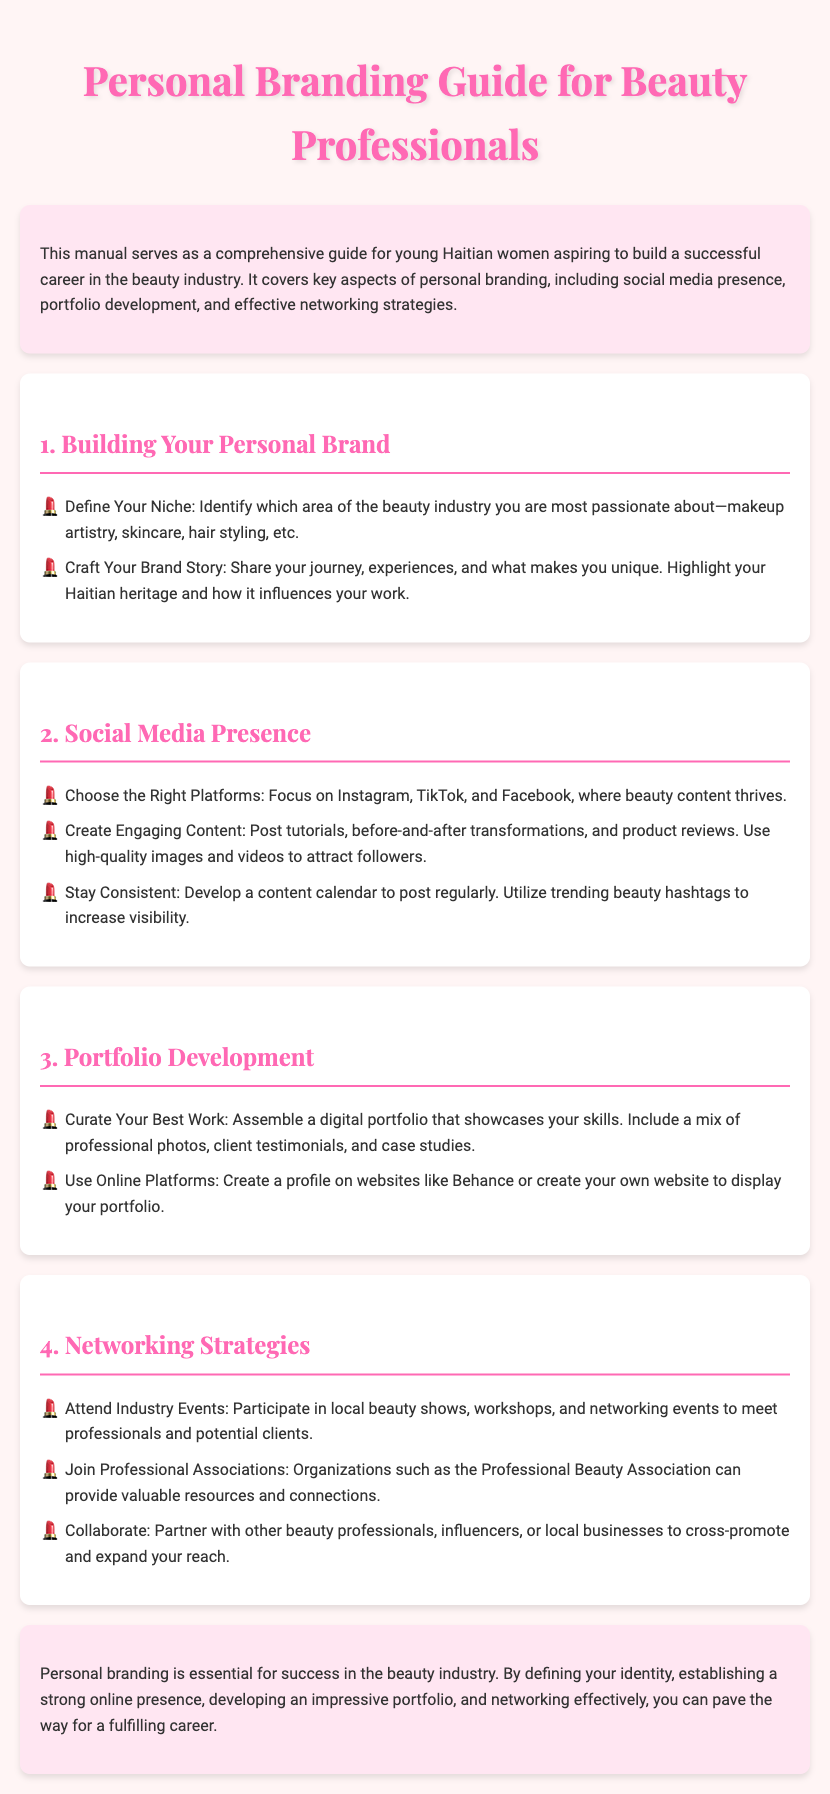What is the title of the manual? The title is clearly stated at the beginning of the document.
Answer: Personal Branding Guide for Beauty Professionals Who is the manual intended for? The introduction specifies the target audience for the manual.
Answer: young Haitian women What are two areas of focus for social media presence? The section on social media outlines important aspects for building an online presence.
Answer: Instagram and TikTok What should you include in your digital portfolio? The portfolio development section mentions key components to showcase your skills.
Answer: professional photos How many main sections are there in the manual? The document consists of distinct sections that each cover a topic related to personal branding.
Answer: Four What is one strategy suggested for networking? The networking strategies section provides actionable advice for establishing connections.
Answer: Attend Industry Events What is emphasized as essential for success in the beauty industry? The conclusion synthesizes the critical focus of the manual.
Answer: Personal branding What is recommended for creating engaging social media content? The social media presence section advises on content creation techniques.
Answer: Post tutorials 